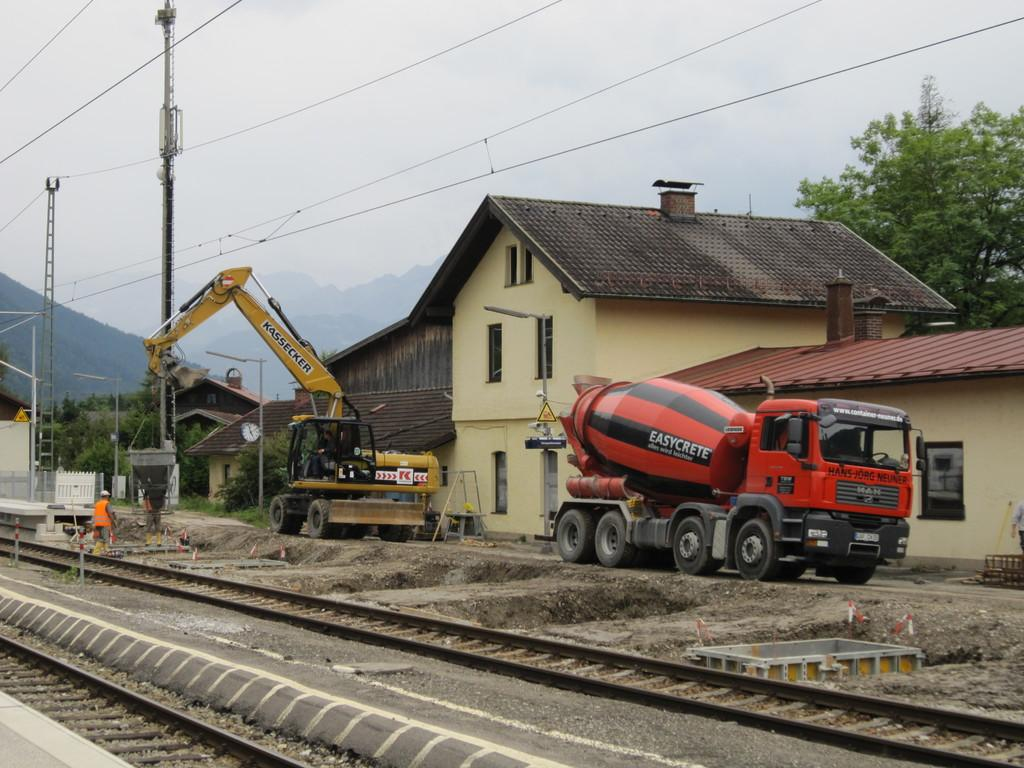Provide a one-sentence caption for the provided image. A black and orange colored cement mixer bears the simplistic brand name Easycrete. 